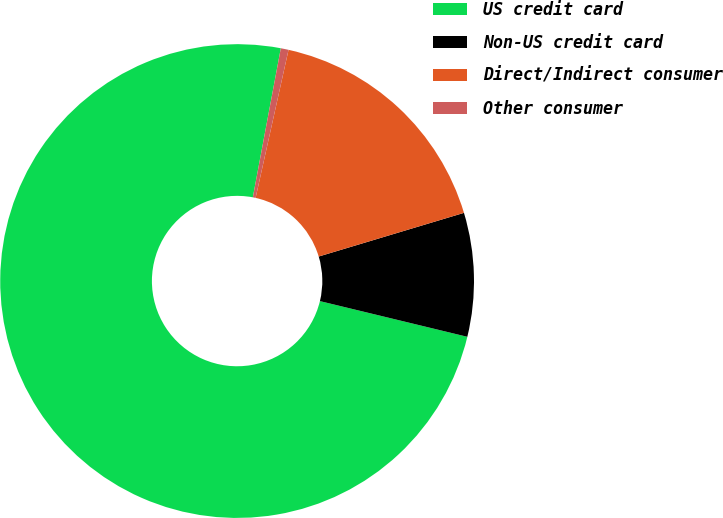Convert chart. <chart><loc_0><loc_0><loc_500><loc_500><pie_chart><fcel>US credit card<fcel>Non-US credit card<fcel>Direct/Indirect consumer<fcel>Other consumer<nl><fcel>74.18%<fcel>8.43%<fcel>16.87%<fcel>0.53%<nl></chart> 